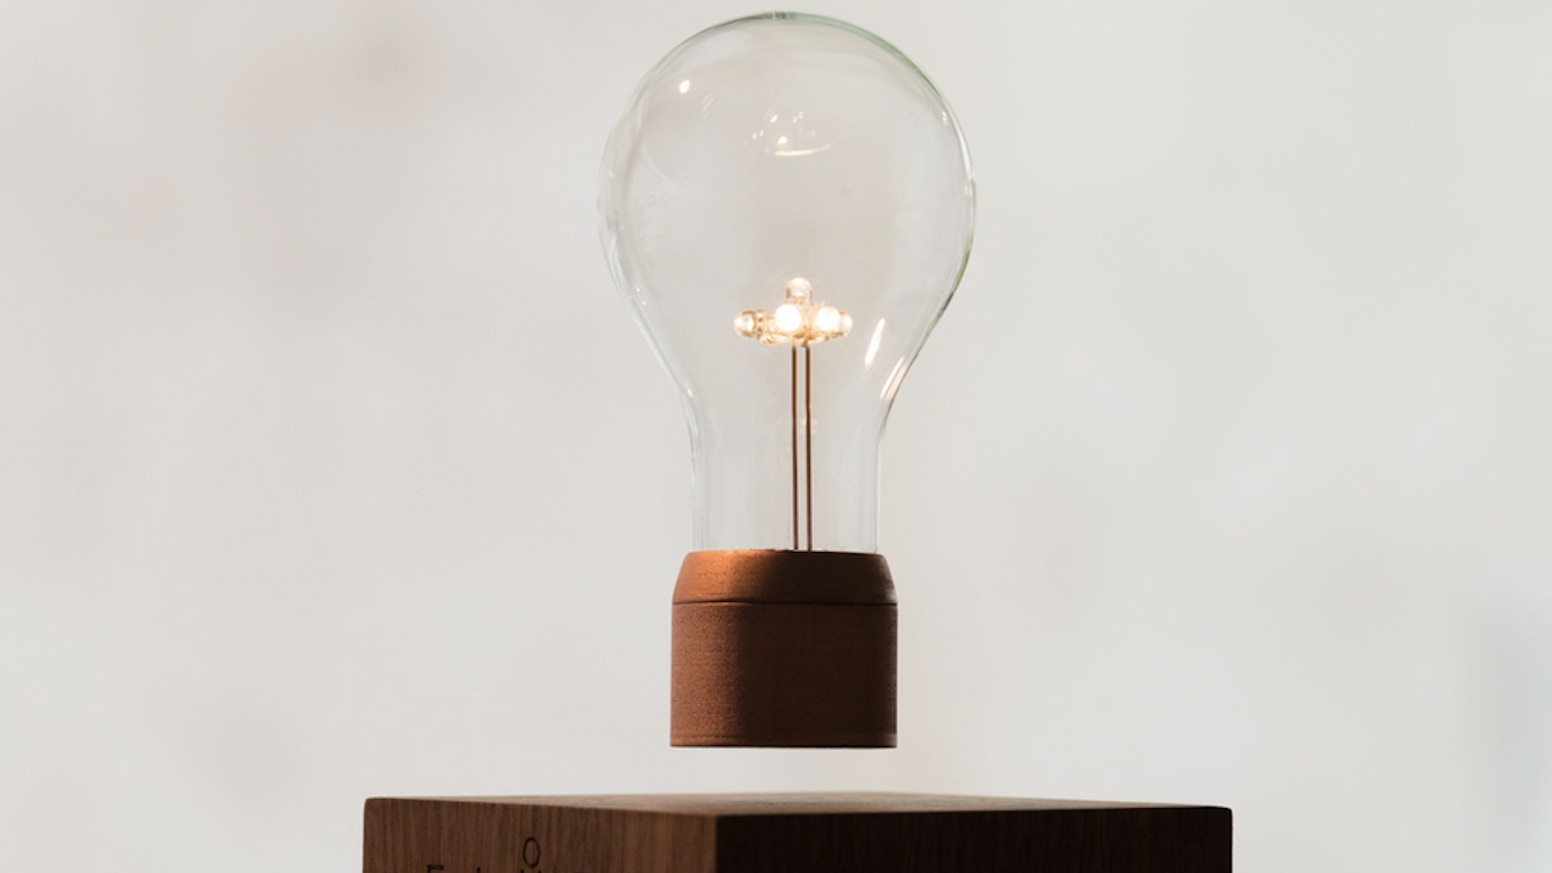What might be the ideal usage scenario for this type of light bulb? This type of light bulb is ideally used in environments where ambiance is a priority over brightness or energy efficiency. The classic design and the warm light output make it perfect for areas like dining rooms, lounges, or vintage-themed cafes where a cozy and inviting atmosphere is desired. It's also well-suited for use in decorative lamps that highlight the bulb as part of the decor. 